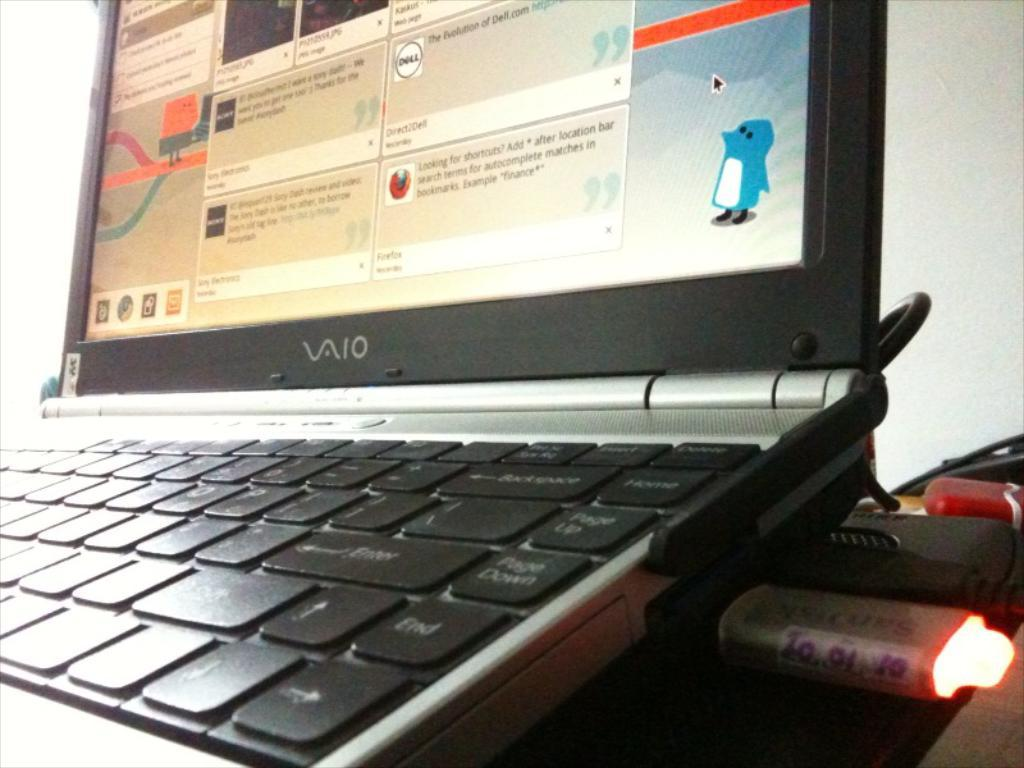<image>
Summarize the visual content of the image. laptop that has a USB that says 100110 on it. 